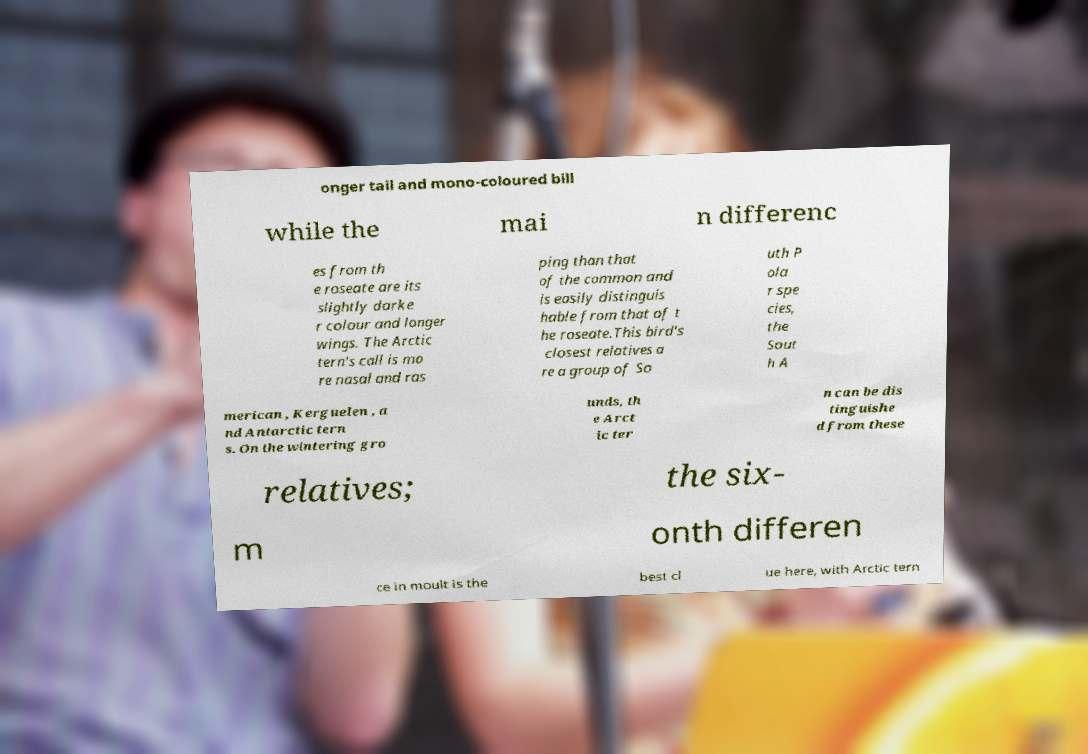Can you accurately transcribe the text from the provided image for me? onger tail and mono-coloured bill while the mai n differenc es from th e roseate are its slightly darke r colour and longer wings. The Arctic tern's call is mo re nasal and ras ping than that of the common and is easily distinguis hable from that of t he roseate.This bird's closest relatives a re a group of So uth P ola r spe cies, the Sout h A merican , Kerguelen , a nd Antarctic tern s. On the wintering gro unds, th e Arct ic ter n can be dis tinguishe d from these relatives; the six- m onth differen ce in moult is the best cl ue here, with Arctic tern 